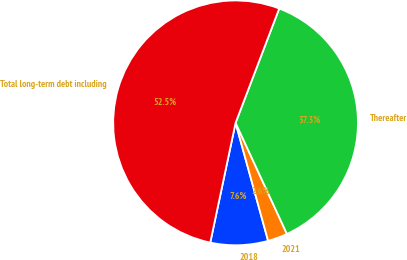<chart> <loc_0><loc_0><loc_500><loc_500><pie_chart><fcel>2018<fcel>2021<fcel>Thereafter<fcel>Total long-term debt including<nl><fcel>7.6%<fcel>2.61%<fcel>37.31%<fcel>52.49%<nl></chart> 